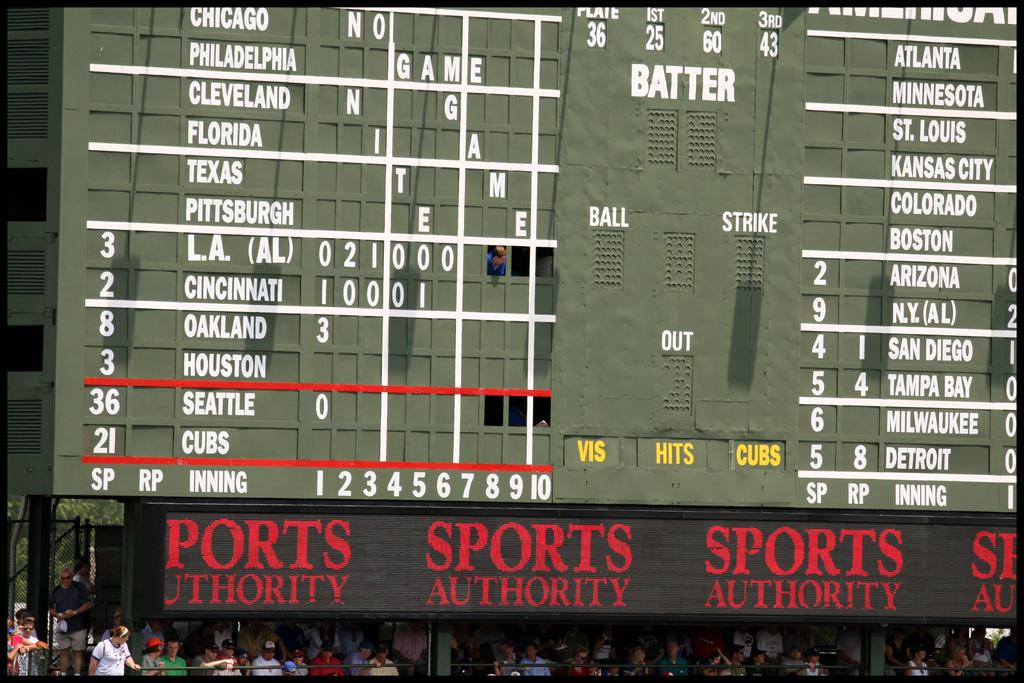<image>
Describe the image concisely. A large green score board with the words Sports Authority on it. 